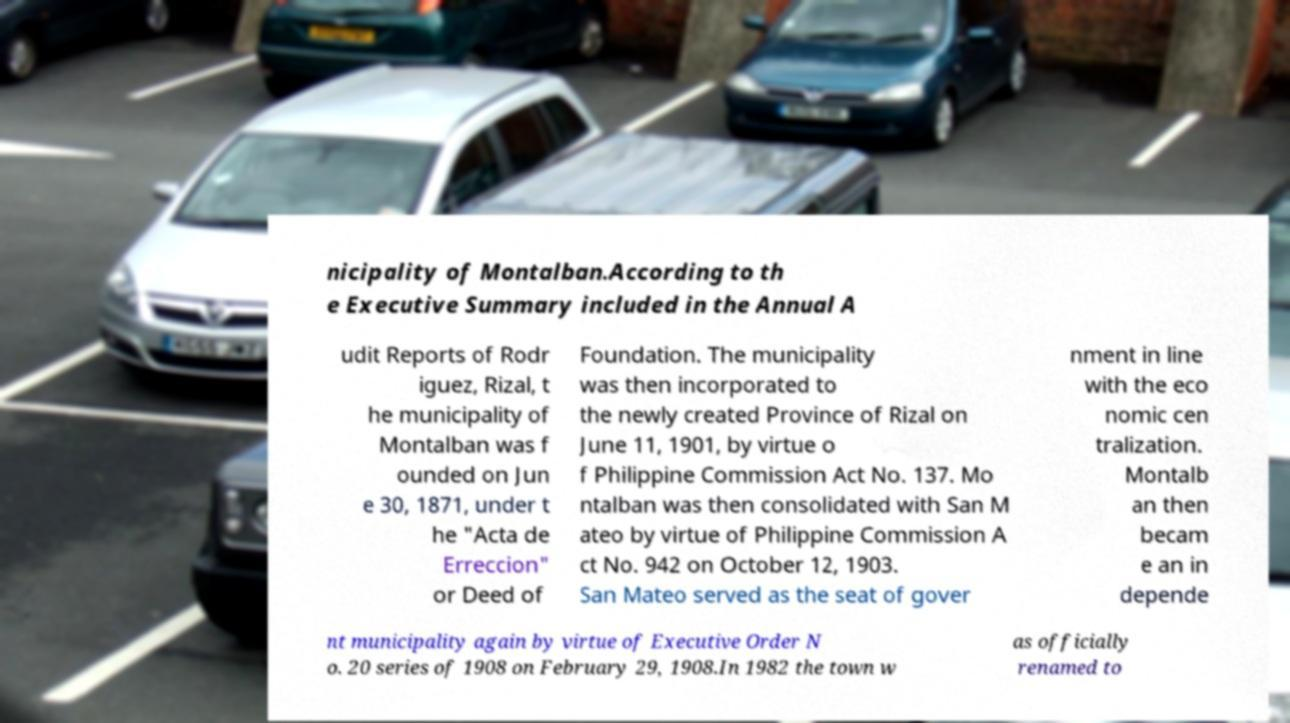I need the written content from this picture converted into text. Can you do that? nicipality of Montalban.According to th e Executive Summary included in the Annual A udit Reports of Rodr iguez, Rizal, t he municipality of Montalban was f ounded on Jun e 30, 1871, under t he "Acta de Erreccion" or Deed of Foundation. The municipality was then incorporated to the newly created Province of Rizal on June 11, 1901, by virtue o f Philippine Commission Act No. 137. Mo ntalban was then consolidated with San M ateo by virtue of Philippine Commission A ct No. 942 on October 12, 1903. San Mateo served as the seat of gover nment in line with the eco nomic cen tralization. Montalb an then becam e an in depende nt municipality again by virtue of Executive Order N o. 20 series of 1908 on February 29, 1908.In 1982 the town w as officially renamed to 